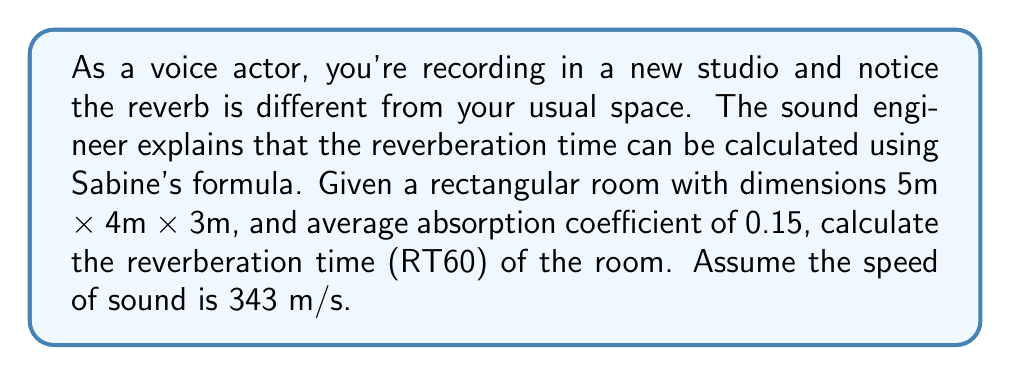What is the answer to this math problem? To solve this problem, we'll use Sabine's formula for reverberation time:

$$RT60 = \frac{0.161 V}{A}$$

Where:
$V$ is the volume of the room in cubic meters
$A$ is the total absorption in sabins

Step 1: Calculate the volume of the room
$$V = 5 \text{ m} \times 4 \text{ m} \times 3 \text{ m} = 60 \text{ m}^3$$

Step 2: Calculate the surface area of the room
$$S = 2(5 \times 4 + 5 \times 3 + 4 \times 3) = 94 \text{ m}^2$$

Step 3: Calculate the total absorption
$$A = \alpha S = 0.15 \times 94 = 14.1 \text{ sabins}$$

Step 4: Apply Sabine's formula
$$RT60 = \frac{0.161 \times 60}{14.1} \approx 0.684 \text{ seconds}$$
Answer: 0.684 seconds 